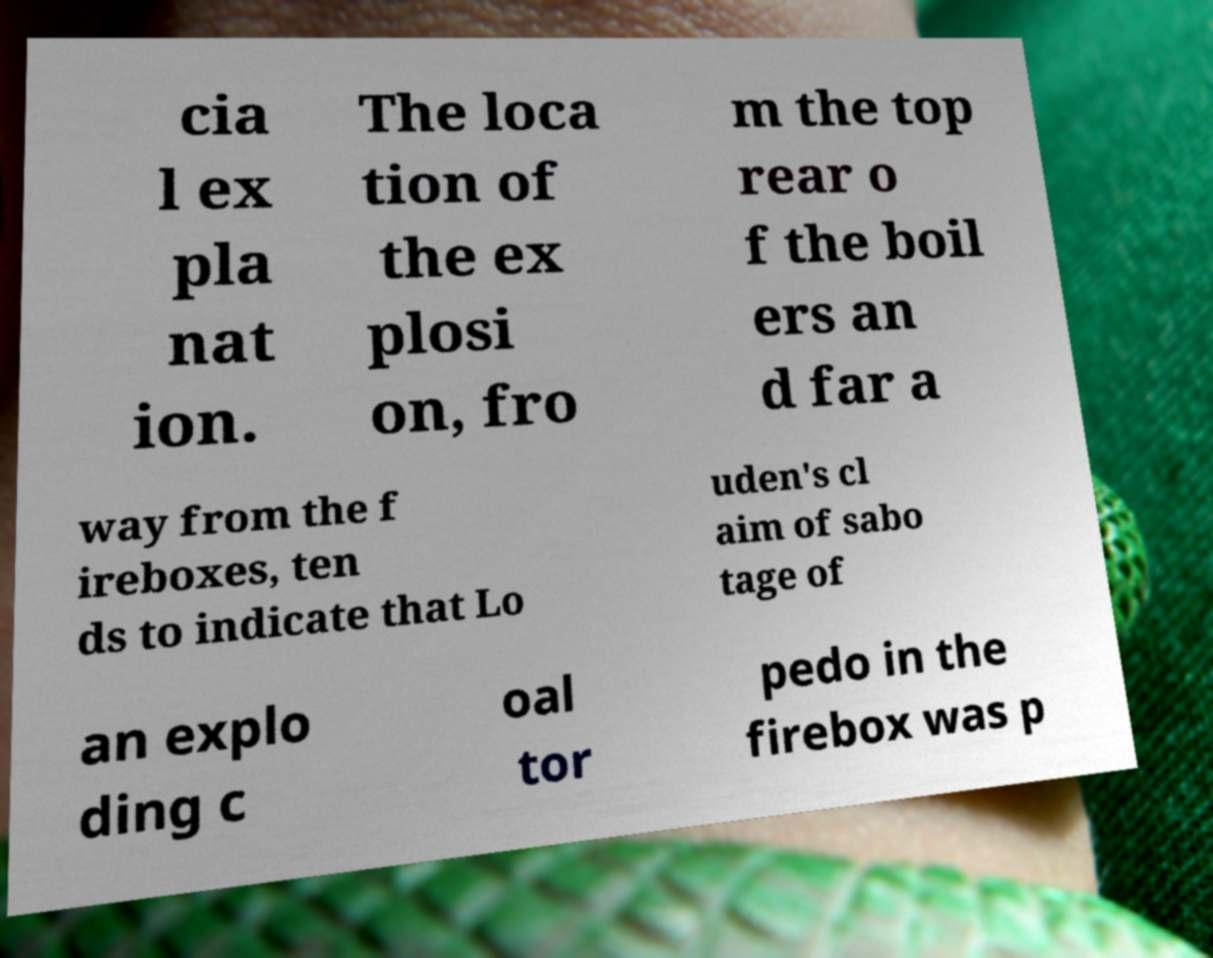Can you read and provide the text displayed in the image?This photo seems to have some interesting text. Can you extract and type it out for me? cia l ex pla nat ion. The loca tion of the ex plosi on, fro m the top rear o f the boil ers an d far a way from the f ireboxes, ten ds to indicate that Lo uden's cl aim of sabo tage of an explo ding c oal tor pedo in the firebox was p 